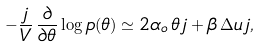<formula> <loc_0><loc_0><loc_500><loc_500>- \frac { j } { V } \, \frac { \partial } { \partial \theta } \log p ( \theta ) \simeq 2 \alpha _ { o } \, \theta \, j + \beta \, \Delta u \, j ,</formula> 